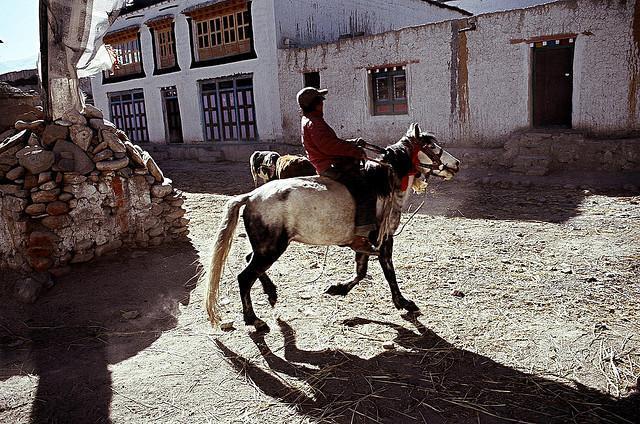How many horses are in the picture?
Give a very brief answer. 1. How many horses are there in the image?
Give a very brief answer. 1. How many people are in the picture?
Give a very brief answer. 1. 